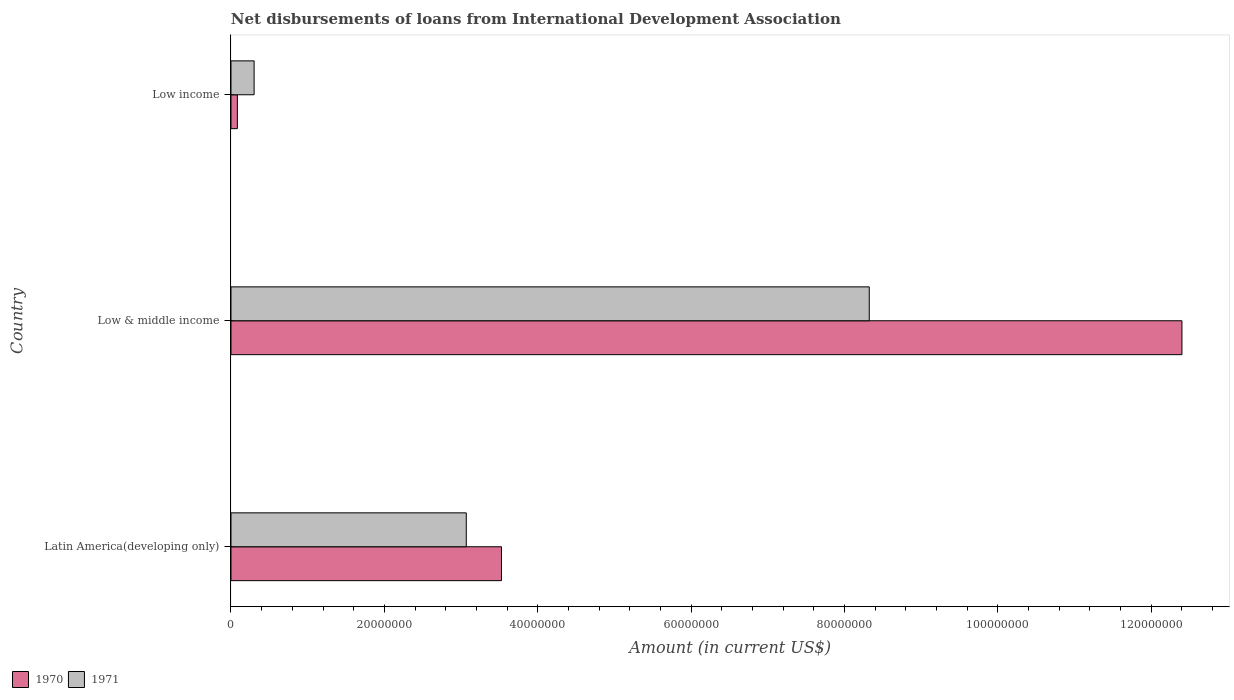Are the number of bars per tick equal to the number of legend labels?
Provide a short and direct response. Yes. Are the number of bars on each tick of the Y-axis equal?
Give a very brief answer. Yes. How many bars are there on the 1st tick from the top?
Offer a very short reply. 2. What is the amount of loans disbursed in 1971 in Latin America(developing only)?
Your answer should be compact. 3.07e+07. Across all countries, what is the maximum amount of loans disbursed in 1970?
Ensure brevity in your answer.  1.24e+08. Across all countries, what is the minimum amount of loans disbursed in 1970?
Your answer should be compact. 8.35e+05. In which country was the amount of loans disbursed in 1970 maximum?
Ensure brevity in your answer.  Low & middle income. What is the total amount of loans disbursed in 1970 in the graph?
Your answer should be compact. 1.60e+08. What is the difference between the amount of loans disbursed in 1971 in Latin America(developing only) and that in Low & middle income?
Keep it short and to the point. -5.25e+07. What is the difference between the amount of loans disbursed in 1970 in Low income and the amount of loans disbursed in 1971 in Latin America(developing only)?
Give a very brief answer. -2.98e+07. What is the average amount of loans disbursed in 1970 per country?
Give a very brief answer. 5.34e+07. What is the difference between the amount of loans disbursed in 1970 and amount of loans disbursed in 1971 in Latin America(developing only)?
Offer a very short reply. 4.59e+06. What is the ratio of the amount of loans disbursed in 1971 in Latin America(developing only) to that in Low & middle income?
Your answer should be very brief. 0.37. Is the amount of loans disbursed in 1970 in Low & middle income less than that in Low income?
Your response must be concise. No. What is the difference between the highest and the second highest amount of loans disbursed in 1971?
Your answer should be compact. 5.25e+07. What is the difference between the highest and the lowest amount of loans disbursed in 1970?
Give a very brief answer. 1.23e+08. In how many countries, is the amount of loans disbursed in 1970 greater than the average amount of loans disbursed in 1970 taken over all countries?
Offer a very short reply. 1. What does the 2nd bar from the bottom in Low & middle income represents?
Offer a terse response. 1971. How many countries are there in the graph?
Provide a short and direct response. 3. What is the difference between two consecutive major ticks on the X-axis?
Keep it short and to the point. 2.00e+07. How many legend labels are there?
Make the answer very short. 2. How are the legend labels stacked?
Offer a terse response. Horizontal. What is the title of the graph?
Keep it short and to the point. Net disbursements of loans from International Development Association. What is the label or title of the X-axis?
Your response must be concise. Amount (in current US$). What is the Amount (in current US$) of 1970 in Latin America(developing only)?
Your response must be concise. 3.53e+07. What is the Amount (in current US$) in 1971 in Latin America(developing only)?
Offer a terse response. 3.07e+07. What is the Amount (in current US$) of 1970 in Low & middle income?
Your answer should be compact. 1.24e+08. What is the Amount (in current US$) of 1971 in Low & middle income?
Your response must be concise. 8.32e+07. What is the Amount (in current US$) in 1970 in Low income?
Provide a succinct answer. 8.35e+05. What is the Amount (in current US$) of 1971 in Low income?
Your answer should be compact. 3.02e+06. Across all countries, what is the maximum Amount (in current US$) in 1970?
Offer a very short reply. 1.24e+08. Across all countries, what is the maximum Amount (in current US$) of 1971?
Your answer should be very brief. 8.32e+07. Across all countries, what is the minimum Amount (in current US$) in 1970?
Your answer should be compact. 8.35e+05. Across all countries, what is the minimum Amount (in current US$) in 1971?
Keep it short and to the point. 3.02e+06. What is the total Amount (in current US$) in 1970 in the graph?
Your answer should be very brief. 1.60e+08. What is the total Amount (in current US$) of 1971 in the graph?
Ensure brevity in your answer.  1.17e+08. What is the difference between the Amount (in current US$) of 1970 in Latin America(developing only) and that in Low & middle income?
Ensure brevity in your answer.  -8.87e+07. What is the difference between the Amount (in current US$) of 1971 in Latin America(developing only) and that in Low & middle income?
Your answer should be very brief. -5.25e+07. What is the difference between the Amount (in current US$) of 1970 in Latin America(developing only) and that in Low income?
Make the answer very short. 3.44e+07. What is the difference between the Amount (in current US$) of 1971 in Latin America(developing only) and that in Low income?
Your answer should be very brief. 2.77e+07. What is the difference between the Amount (in current US$) of 1970 in Low & middle income and that in Low income?
Ensure brevity in your answer.  1.23e+08. What is the difference between the Amount (in current US$) of 1971 in Low & middle income and that in Low income?
Your response must be concise. 8.02e+07. What is the difference between the Amount (in current US$) of 1970 in Latin America(developing only) and the Amount (in current US$) of 1971 in Low & middle income?
Provide a short and direct response. -4.80e+07. What is the difference between the Amount (in current US$) of 1970 in Latin America(developing only) and the Amount (in current US$) of 1971 in Low income?
Offer a very short reply. 3.23e+07. What is the difference between the Amount (in current US$) of 1970 in Low & middle income and the Amount (in current US$) of 1971 in Low income?
Give a very brief answer. 1.21e+08. What is the average Amount (in current US$) in 1970 per country?
Give a very brief answer. 5.34e+07. What is the average Amount (in current US$) in 1971 per country?
Give a very brief answer. 3.90e+07. What is the difference between the Amount (in current US$) in 1970 and Amount (in current US$) in 1971 in Latin America(developing only)?
Your answer should be compact. 4.59e+06. What is the difference between the Amount (in current US$) of 1970 and Amount (in current US$) of 1971 in Low & middle income?
Make the answer very short. 4.08e+07. What is the difference between the Amount (in current US$) of 1970 and Amount (in current US$) of 1971 in Low income?
Provide a succinct answer. -2.18e+06. What is the ratio of the Amount (in current US$) in 1970 in Latin America(developing only) to that in Low & middle income?
Offer a very short reply. 0.28. What is the ratio of the Amount (in current US$) of 1971 in Latin America(developing only) to that in Low & middle income?
Your answer should be compact. 0.37. What is the ratio of the Amount (in current US$) in 1970 in Latin America(developing only) to that in Low income?
Offer a terse response. 42.24. What is the ratio of the Amount (in current US$) in 1971 in Latin America(developing only) to that in Low income?
Make the answer very short. 10.17. What is the ratio of the Amount (in current US$) of 1970 in Low & middle income to that in Low income?
Provide a succinct answer. 148.5. What is the ratio of the Amount (in current US$) of 1971 in Low & middle income to that in Low income?
Make the answer very short. 27.59. What is the difference between the highest and the second highest Amount (in current US$) of 1970?
Ensure brevity in your answer.  8.87e+07. What is the difference between the highest and the second highest Amount (in current US$) in 1971?
Your response must be concise. 5.25e+07. What is the difference between the highest and the lowest Amount (in current US$) in 1970?
Your answer should be compact. 1.23e+08. What is the difference between the highest and the lowest Amount (in current US$) in 1971?
Make the answer very short. 8.02e+07. 